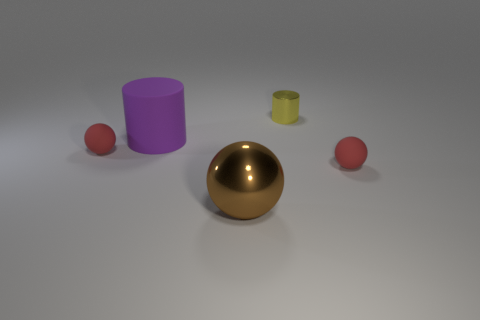There is a brown ball that is in front of the tiny cylinder; what is its material?
Your response must be concise. Metal. How many small yellow rubber things are the same shape as the large purple rubber object?
Ensure brevity in your answer.  0. What is the cylinder that is right of the large purple rubber cylinder on the left side of the shiny cylinder made of?
Your answer should be compact. Metal. Is there a small cylinder made of the same material as the large brown ball?
Offer a terse response. Yes. There is a big brown thing; what shape is it?
Provide a short and direct response. Sphere. How many large purple matte objects are there?
Your answer should be very brief. 1. There is a matte object that is behind the tiny red thing on the left side of the small metal cylinder; what is its color?
Provide a succinct answer. Purple. What is the color of the cylinder that is the same size as the brown thing?
Ensure brevity in your answer.  Purple. Is there a tiny yellow matte sphere?
Make the answer very short. No. There is a big brown metallic object in front of the small metallic thing; what is its shape?
Give a very brief answer. Sphere. 